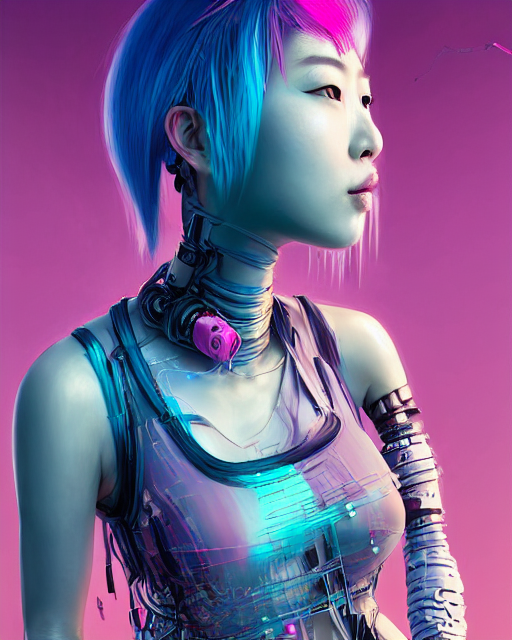How do the robot's facial features compare to human expressions? The robot's facial features exhibit a striking resemblance to human expressions, with clear attention to detail such as the contours of the cheeks and the gaze of the eyes. There is an inscrutable depth to the gaze that implicates a complex artificial intelligence, capable of mimicking human emotions. 